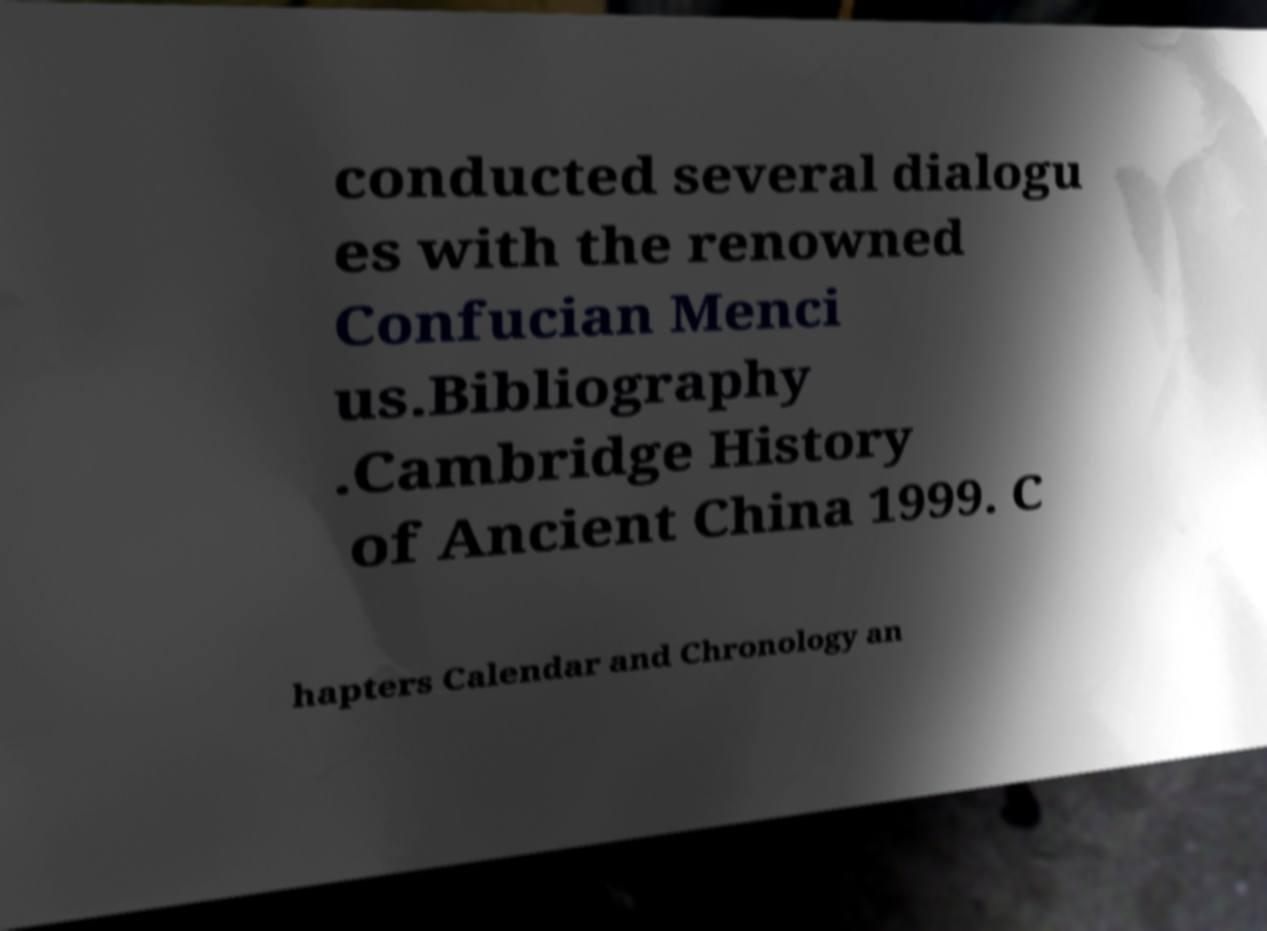Please read and relay the text visible in this image. What does it say? conducted several dialogu es with the renowned Confucian Menci us.Bibliography .Cambridge History of Ancient China 1999. C hapters Calendar and Chronology an 